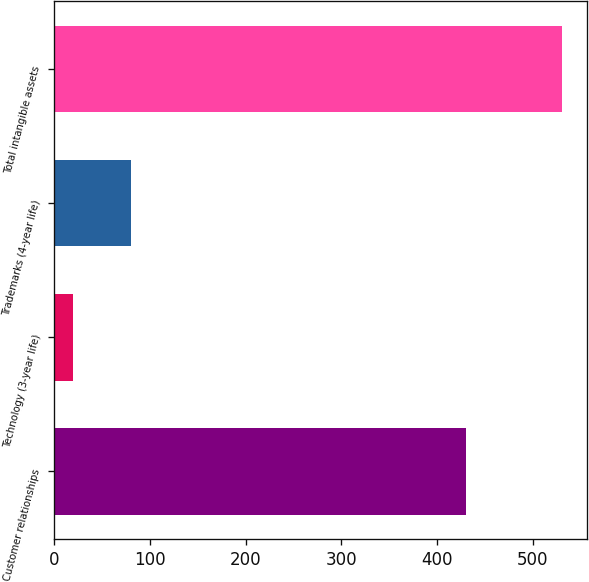Convert chart. <chart><loc_0><loc_0><loc_500><loc_500><bar_chart><fcel>Customer relationships<fcel>Technology (3-year life)<fcel>Trademarks (4-year life)<fcel>Total intangible assets<nl><fcel>430<fcel>20<fcel>80<fcel>530<nl></chart> 